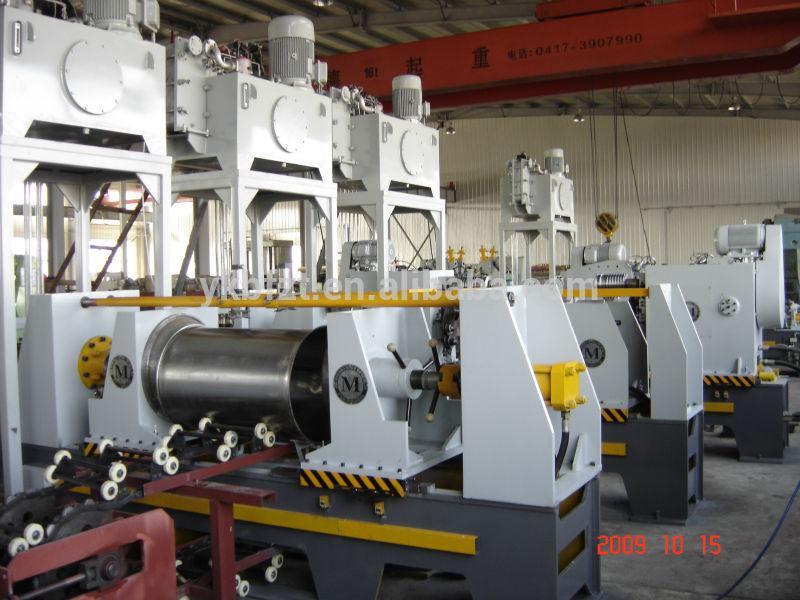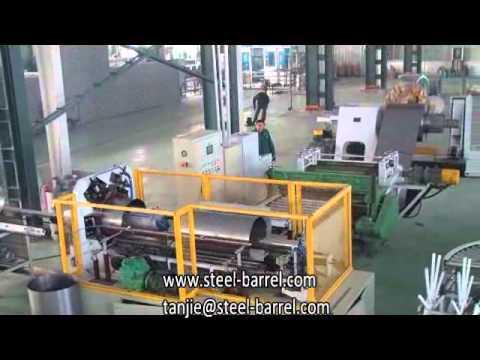The first image is the image on the left, the second image is the image on the right. For the images displayed, is the sentence "People work near silver barrels in at least one of the images." factually correct? Answer yes or no. No. 